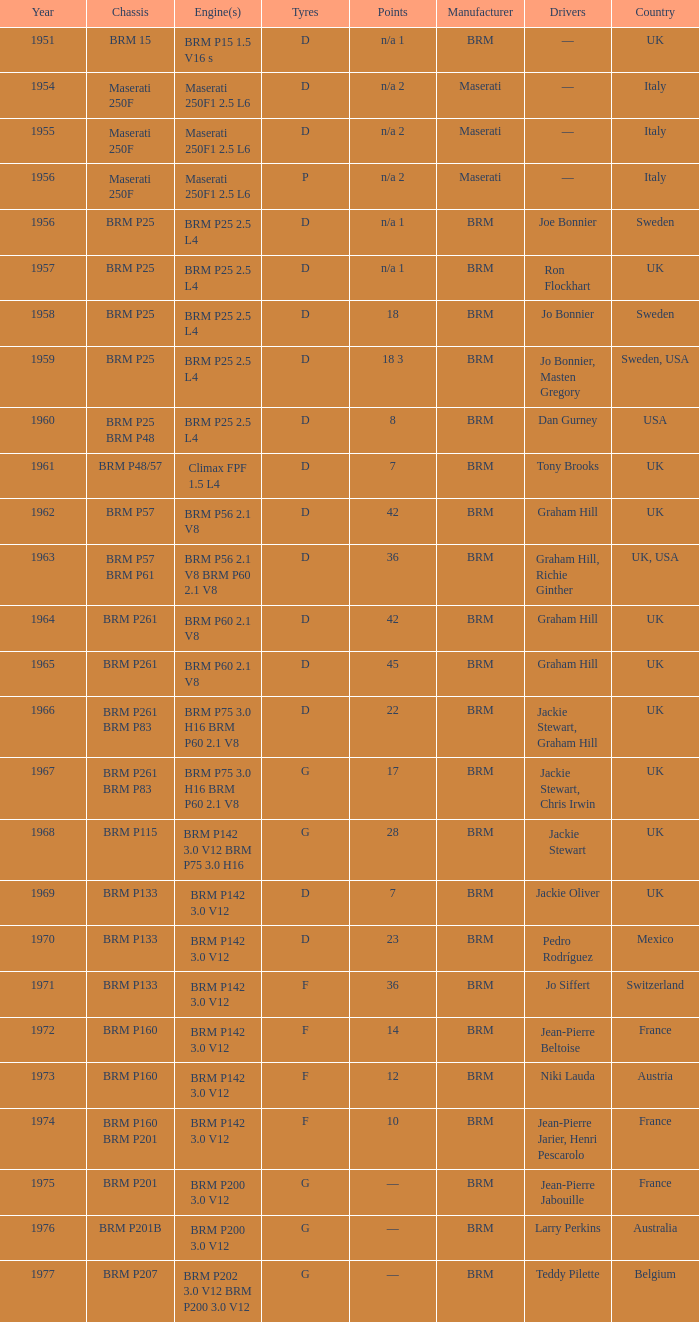What is the significant event for 1974? 10.0. 